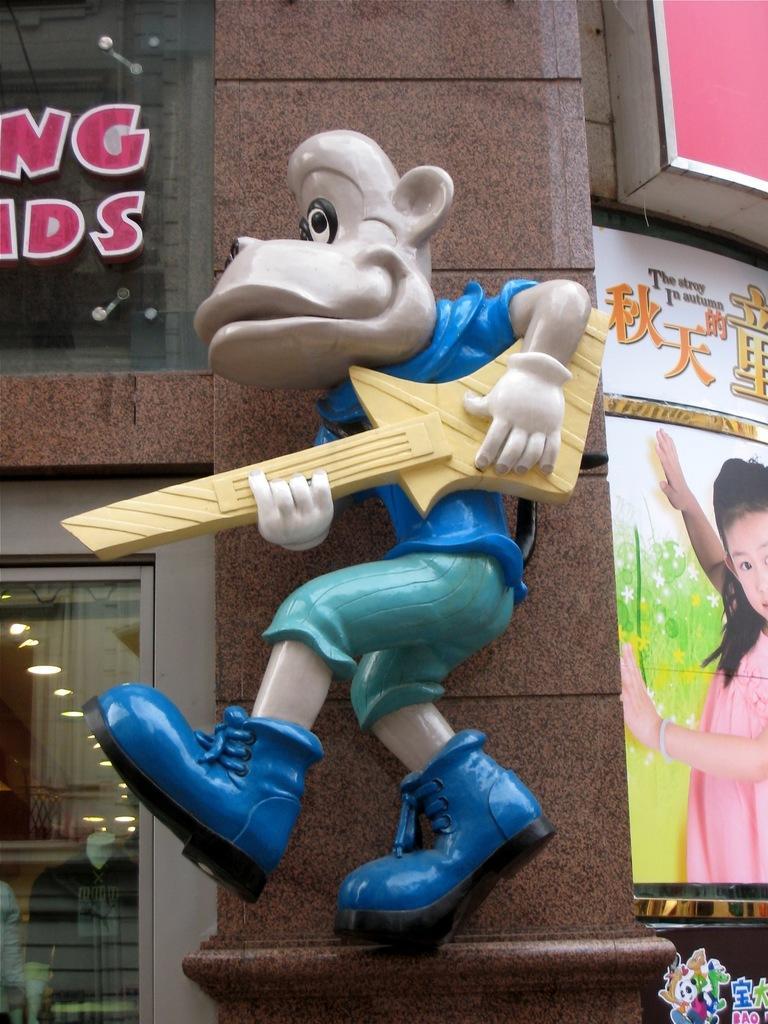In one or two sentences, can you explain what this image depicts? In front of the image there is a doll structure on the pillar of a building, on the either side of the structure, there are posters and name boards on the glass windows. 